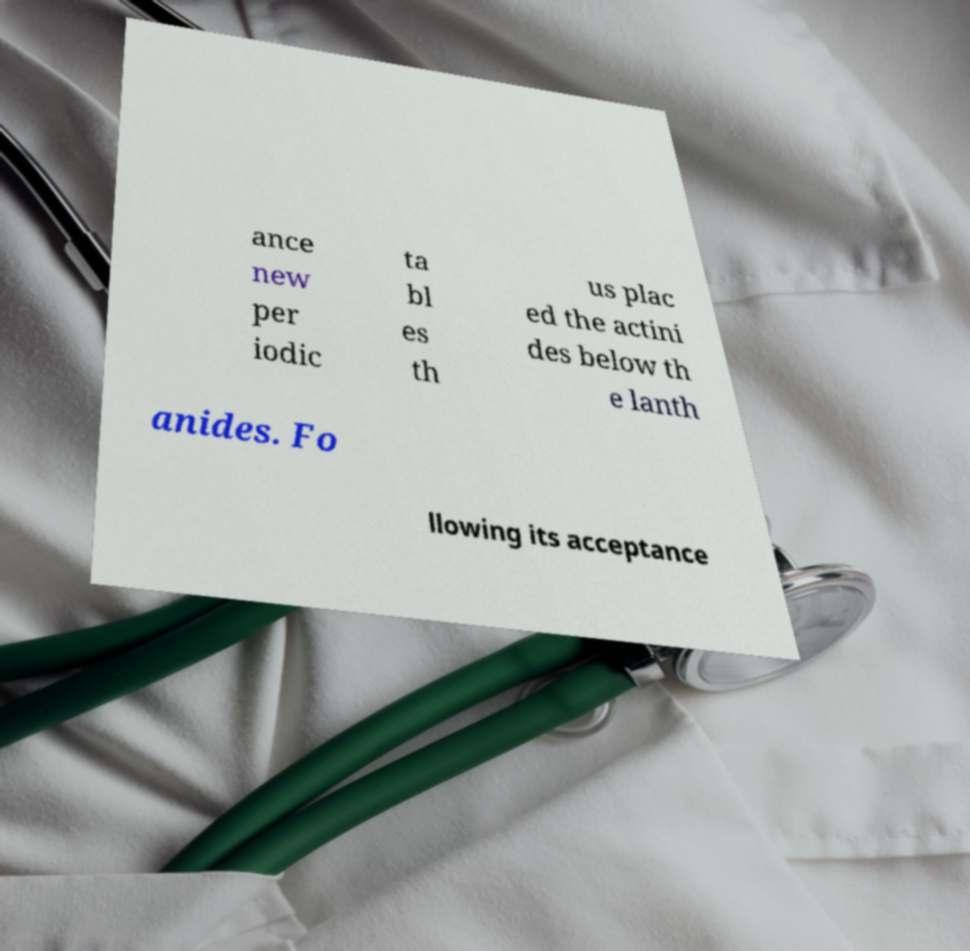There's text embedded in this image that I need extracted. Can you transcribe it verbatim? ance new per iodic ta bl es th us plac ed the actini des below th e lanth anides. Fo llowing its acceptance 